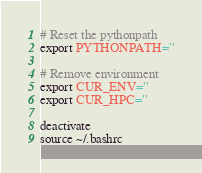<code> <loc_0><loc_0><loc_500><loc_500><_Bash_>
# Reset the pythonpath
export PYTHONPATH=''

# Remove environment
export CUR_ENV=''
export CUR_HPC=''

deactivate
source ~/.bashrc</code> 